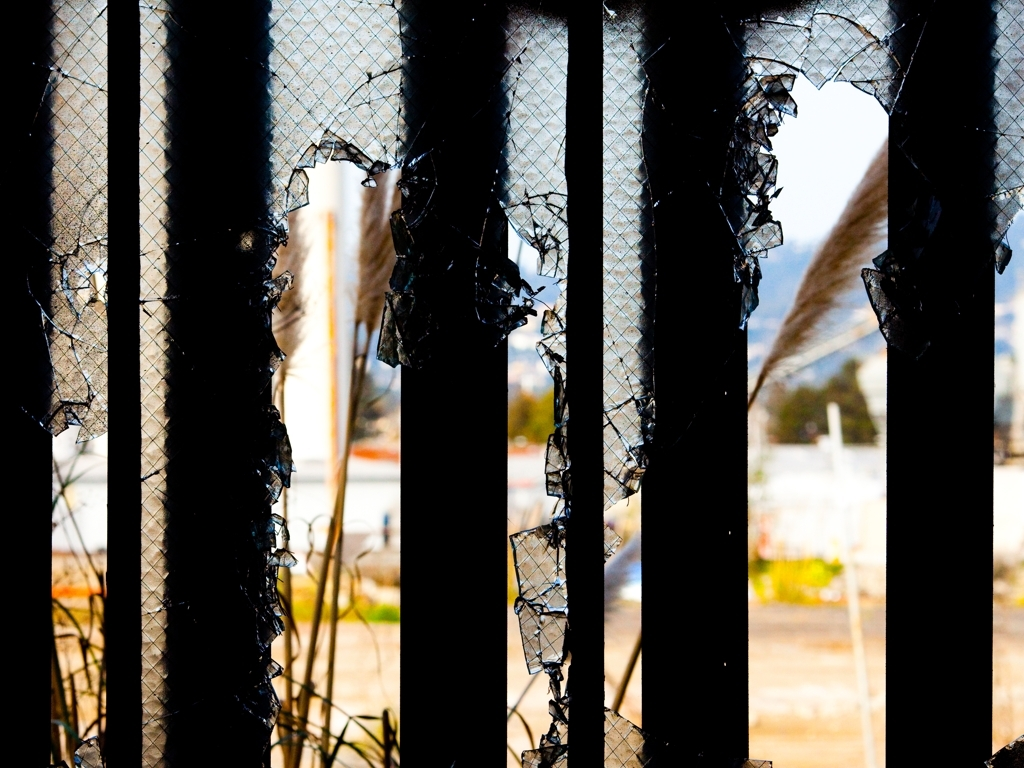What might have caused the damage to the barrier? The jagged edges and gaping holes in the barrier suggest that it could have been damaged by forceful impact, possibly from debris during severe weather conditions, vandalism, or an accident. 